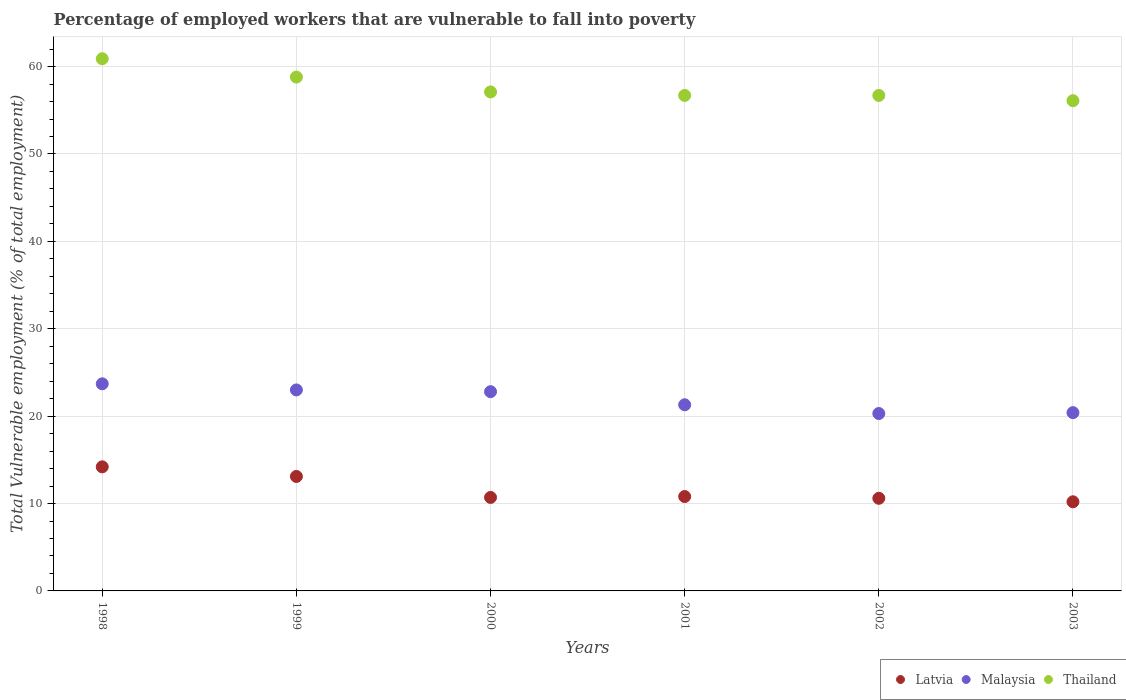How many different coloured dotlines are there?
Keep it short and to the point. 3. What is the percentage of employed workers who are vulnerable to fall into poverty in Malaysia in 2003?
Offer a terse response. 20.4. Across all years, what is the maximum percentage of employed workers who are vulnerable to fall into poverty in Malaysia?
Offer a very short reply. 23.7. Across all years, what is the minimum percentage of employed workers who are vulnerable to fall into poverty in Malaysia?
Give a very brief answer. 20.3. In which year was the percentage of employed workers who are vulnerable to fall into poverty in Malaysia minimum?
Offer a terse response. 2002. What is the total percentage of employed workers who are vulnerable to fall into poverty in Latvia in the graph?
Your answer should be compact. 69.6. What is the difference between the percentage of employed workers who are vulnerable to fall into poverty in Thailand in 2000 and that in 2002?
Your answer should be compact. 0.4. What is the difference between the percentage of employed workers who are vulnerable to fall into poverty in Malaysia in 2002 and the percentage of employed workers who are vulnerable to fall into poverty in Latvia in 2001?
Provide a succinct answer. 9.5. What is the average percentage of employed workers who are vulnerable to fall into poverty in Latvia per year?
Your answer should be compact. 11.6. In the year 1999, what is the difference between the percentage of employed workers who are vulnerable to fall into poverty in Thailand and percentage of employed workers who are vulnerable to fall into poverty in Latvia?
Your answer should be compact. 45.7. What is the ratio of the percentage of employed workers who are vulnerable to fall into poverty in Thailand in 2000 to that in 2002?
Your answer should be very brief. 1.01. What is the difference between the highest and the second highest percentage of employed workers who are vulnerable to fall into poverty in Malaysia?
Ensure brevity in your answer.  0.7. Is it the case that in every year, the sum of the percentage of employed workers who are vulnerable to fall into poverty in Latvia and percentage of employed workers who are vulnerable to fall into poverty in Malaysia  is greater than the percentage of employed workers who are vulnerable to fall into poverty in Thailand?
Provide a short and direct response. No. Does the percentage of employed workers who are vulnerable to fall into poverty in Latvia monotonically increase over the years?
Provide a short and direct response. No. Is the percentage of employed workers who are vulnerable to fall into poverty in Latvia strictly greater than the percentage of employed workers who are vulnerable to fall into poverty in Malaysia over the years?
Provide a short and direct response. No. How many dotlines are there?
Ensure brevity in your answer.  3. What is the difference between two consecutive major ticks on the Y-axis?
Provide a short and direct response. 10. Are the values on the major ticks of Y-axis written in scientific E-notation?
Your response must be concise. No. Does the graph contain any zero values?
Ensure brevity in your answer.  No. Does the graph contain grids?
Give a very brief answer. Yes. Where does the legend appear in the graph?
Provide a succinct answer. Bottom right. What is the title of the graph?
Keep it short and to the point. Percentage of employed workers that are vulnerable to fall into poverty. What is the label or title of the Y-axis?
Provide a short and direct response. Total Vulnerable employment (% of total employment). What is the Total Vulnerable employment (% of total employment) in Latvia in 1998?
Offer a terse response. 14.2. What is the Total Vulnerable employment (% of total employment) of Malaysia in 1998?
Your answer should be very brief. 23.7. What is the Total Vulnerable employment (% of total employment) of Thailand in 1998?
Offer a terse response. 60.9. What is the Total Vulnerable employment (% of total employment) in Latvia in 1999?
Provide a succinct answer. 13.1. What is the Total Vulnerable employment (% of total employment) in Malaysia in 1999?
Your response must be concise. 23. What is the Total Vulnerable employment (% of total employment) in Thailand in 1999?
Keep it short and to the point. 58.8. What is the Total Vulnerable employment (% of total employment) of Latvia in 2000?
Keep it short and to the point. 10.7. What is the Total Vulnerable employment (% of total employment) of Malaysia in 2000?
Your answer should be compact. 22.8. What is the Total Vulnerable employment (% of total employment) in Thailand in 2000?
Your response must be concise. 57.1. What is the Total Vulnerable employment (% of total employment) in Latvia in 2001?
Your response must be concise. 10.8. What is the Total Vulnerable employment (% of total employment) of Malaysia in 2001?
Provide a succinct answer. 21.3. What is the Total Vulnerable employment (% of total employment) of Thailand in 2001?
Offer a very short reply. 56.7. What is the Total Vulnerable employment (% of total employment) in Latvia in 2002?
Your answer should be very brief. 10.6. What is the Total Vulnerable employment (% of total employment) of Malaysia in 2002?
Your answer should be compact. 20.3. What is the Total Vulnerable employment (% of total employment) of Thailand in 2002?
Provide a short and direct response. 56.7. What is the Total Vulnerable employment (% of total employment) in Latvia in 2003?
Offer a terse response. 10.2. What is the Total Vulnerable employment (% of total employment) in Malaysia in 2003?
Keep it short and to the point. 20.4. What is the Total Vulnerable employment (% of total employment) of Thailand in 2003?
Make the answer very short. 56.1. Across all years, what is the maximum Total Vulnerable employment (% of total employment) of Latvia?
Give a very brief answer. 14.2. Across all years, what is the maximum Total Vulnerable employment (% of total employment) in Malaysia?
Give a very brief answer. 23.7. Across all years, what is the maximum Total Vulnerable employment (% of total employment) of Thailand?
Your answer should be very brief. 60.9. Across all years, what is the minimum Total Vulnerable employment (% of total employment) of Latvia?
Your response must be concise. 10.2. Across all years, what is the minimum Total Vulnerable employment (% of total employment) of Malaysia?
Your answer should be very brief. 20.3. Across all years, what is the minimum Total Vulnerable employment (% of total employment) of Thailand?
Ensure brevity in your answer.  56.1. What is the total Total Vulnerable employment (% of total employment) of Latvia in the graph?
Provide a succinct answer. 69.6. What is the total Total Vulnerable employment (% of total employment) in Malaysia in the graph?
Make the answer very short. 131.5. What is the total Total Vulnerable employment (% of total employment) in Thailand in the graph?
Your response must be concise. 346.3. What is the difference between the Total Vulnerable employment (% of total employment) in Latvia in 1998 and that in 1999?
Give a very brief answer. 1.1. What is the difference between the Total Vulnerable employment (% of total employment) of Malaysia in 1998 and that in 1999?
Provide a short and direct response. 0.7. What is the difference between the Total Vulnerable employment (% of total employment) of Thailand in 1998 and that in 1999?
Offer a very short reply. 2.1. What is the difference between the Total Vulnerable employment (% of total employment) of Latvia in 1998 and that in 2000?
Give a very brief answer. 3.5. What is the difference between the Total Vulnerable employment (% of total employment) in Thailand in 1998 and that in 2000?
Provide a short and direct response. 3.8. What is the difference between the Total Vulnerable employment (% of total employment) of Latvia in 1998 and that in 2001?
Your answer should be very brief. 3.4. What is the difference between the Total Vulnerable employment (% of total employment) of Malaysia in 1998 and that in 2001?
Your response must be concise. 2.4. What is the difference between the Total Vulnerable employment (% of total employment) in Latvia in 1998 and that in 2002?
Provide a succinct answer. 3.6. What is the difference between the Total Vulnerable employment (% of total employment) of Malaysia in 1998 and that in 2002?
Ensure brevity in your answer.  3.4. What is the difference between the Total Vulnerable employment (% of total employment) in Thailand in 1998 and that in 2002?
Offer a very short reply. 4.2. What is the difference between the Total Vulnerable employment (% of total employment) of Thailand in 1998 and that in 2003?
Give a very brief answer. 4.8. What is the difference between the Total Vulnerable employment (% of total employment) in Malaysia in 1999 and that in 2000?
Your answer should be compact. 0.2. What is the difference between the Total Vulnerable employment (% of total employment) in Thailand in 1999 and that in 2000?
Ensure brevity in your answer.  1.7. What is the difference between the Total Vulnerable employment (% of total employment) in Latvia in 1999 and that in 2001?
Offer a terse response. 2.3. What is the difference between the Total Vulnerable employment (% of total employment) of Thailand in 1999 and that in 2001?
Your response must be concise. 2.1. What is the difference between the Total Vulnerable employment (% of total employment) of Latvia in 1999 and that in 2002?
Give a very brief answer. 2.5. What is the difference between the Total Vulnerable employment (% of total employment) of Malaysia in 1999 and that in 2002?
Your answer should be compact. 2.7. What is the difference between the Total Vulnerable employment (% of total employment) of Thailand in 1999 and that in 2003?
Offer a very short reply. 2.7. What is the difference between the Total Vulnerable employment (% of total employment) in Latvia in 2000 and that in 2001?
Your response must be concise. -0.1. What is the difference between the Total Vulnerable employment (% of total employment) of Malaysia in 2000 and that in 2001?
Ensure brevity in your answer.  1.5. What is the difference between the Total Vulnerable employment (% of total employment) in Latvia in 2000 and that in 2002?
Ensure brevity in your answer.  0.1. What is the difference between the Total Vulnerable employment (% of total employment) in Malaysia in 2000 and that in 2002?
Your response must be concise. 2.5. What is the difference between the Total Vulnerable employment (% of total employment) of Latvia in 2000 and that in 2003?
Offer a very short reply. 0.5. What is the difference between the Total Vulnerable employment (% of total employment) of Latvia in 2001 and that in 2002?
Your answer should be very brief. 0.2. What is the difference between the Total Vulnerable employment (% of total employment) of Thailand in 2001 and that in 2002?
Offer a very short reply. 0. What is the difference between the Total Vulnerable employment (% of total employment) of Latvia in 2001 and that in 2003?
Your response must be concise. 0.6. What is the difference between the Total Vulnerable employment (% of total employment) in Malaysia in 2001 and that in 2003?
Make the answer very short. 0.9. What is the difference between the Total Vulnerable employment (% of total employment) in Thailand in 2001 and that in 2003?
Give a very brief answer. 0.6. What is the difference between the Total Vulnerable employment (% of total employment) in Latvia in 2002 and that in 2003?
Your answer should be very brief. 0.4. What is the difference between the Total Vulnerable employment (% of total employment) in Latvia in 1998 and the Total Vulnerable employment (% of total employment) in Malaysia in 1999?
Keep it short and to the point. -8.8. What is the difference between the Total Vulnerable employment (% of total employment) in Latvia in 1998 and the Total Vulnerable employment (% of total employment) in Thailand in 1999?
Your answer should be compact. -44.6. What is the difference between the Total Vulnerable employment (% of total employment) of Malaysia in 1998 and the Total Vulnerable employment (% of total employment) of Thailand in 1999?
Keep it short and to the point. -35.1. What is the difference between the Total Vulnerable employment (% of total employment) of Latvia in 1998 and the Total Vulnerable employment (% of total employment) of Thailand in 2000?
Provide a short and direct response. -42.9. What is the difference between the Total Vulnerable employment (% of total employment) of Malaysia in 1998 and the Total Vulnerable employment (% of total employment) of Thailand in 2000?
Ensure brevity in your answer.  -33.4. What is the difference between the Total Vulnerable employment (% of total employment) of Latvia in 1998 and the Total Vulnerable employment (% of total employment) of Malaysia in 2001?
Make the answer very short. -7.1. What is the difference between the Total Vulnerable employment (% of total employment) of Latvia in 1998 and the Total Vulnerable employment (% of total employment) of Thailand in 2001?
Your response must be concise. -42.5. What is the difference between the Total Vulnerable employment (% of total employment) of Malaysia in 1998 and the Total Vulnerable employment (% of total employment) of Thailand in 2001?
Your answer should be very brief. -33. What is the difference between the Total Vulnerable employment (% of total employment) of Latvia in 1998 and the Total Vulnerable employment (% of total employment) of Thailand in 2002?
Ensure brevity in your answer.  -42.5. What is the difference between the Total Vulnerable employment (% of total employment) of Malaysia in 1998 and the Total Vulnerable employment (% of total employment) of Thailand in 2002?
Your answer should be very brief. -33. What is the difference between the Total Vulnerable employment (% of total employment) of Latvia in 1998 and the Total Vulnerable employment (% of total employment) of Thailand in 2003?
Give a very brief answer. -41.9. What is the difference between the Total Vulnerable employment (% of total employment) in Malaysia in 1998 and the Total Vulnerable employment (% of total employment) in Thailand in 2003?
Ensure brevity in your answer.  -32.4. What is the difference between the Total Vulnerable employment (% of total employment) of Latvia in 1999 and the Total Vulnerable employment (% of total employment) of Malaysia in 2000?
Offer a terse response. -9.7. What is the difference between the Total Vulnerable employment (% of total employment) of Latvia in 1999 and the Total Vulnerable employment (% of total employment) of Thailand in 2000?
Your answer should be compact. -44. What is the difference between the Total Vulnerable employment (% of total employment) in Malaysia in 1999 and the Total Vulnerable employment (% of total employment) in Thailand in 2000?
Offer a terse response. -34.1. What is the difference between the Total Vulnerable employment (% of total employment) of Latvia in 1999 and the Total Vulnerable employment (% of total employment) of Malaysia in 2001?
Make the answer very short. -8.2. What is the difference between the Total Vulnerable employment (% of total employment) of Latvia in 1999 and the Total Vulnerable employment (% of total employment) of Thailand in 2001?
Provide a short and direct response. -43.6. What is the difference between the Total Vulnerable employment (% of total employment) of Malaysia in 1999 and the Total Vulnerable employment (% of total employment) of Thailand in 2001?
Ensure brevity in your answer.  -33.7. What is the difference between the Total Vulnerable employment (% of total employment) of Latvia in 1999 and the Total Vulnerable employment (% of total employment) of Thailand in 2002?
Give a very brief answer. -43.6. What is the difference between the Total Vulnerable employment (% of total employment) of Malaysia in 1999 and the Total Vulnerable employment (% of total employment) of Thailand in 2002?
Provide a short and direct response. -33.7. What is the difference between the Total Vulnerable employment (% of total employment) of Latvia in 1999 and the Total Vulnerable employment (% of total employment) of Thailand in 2003?
Your response must be concise. -43. What is the difference between the Total Vulnerable employment (% of total employment) in Malaysia in 1999 and the Total Vulnerable employment (% of total employment) in Thailand in 2003?
Provide a succinct answer. -33.1. What is the difference between the Total Vulnerable employment (% of total employment) in Latvia in 2000 and the Total Vulnerable employment (% of total employment) in Thailand in 2001?
Provide a short and direct response. -46. What is the difference between the Total Vulnerable employment (% of total employment) of Malaysia in 2000 and the Total Vulnerable employment (% of total employment) of Thailand in 2001?
Offer a terse response. -33.9. What is the difference between the Total Vulnerable employment (% of total employment) of Latvia in 2000 and the Total Vulnerable employment (% of total employment) of Malaysia in 2002?
Your answer should be compact. -9.6. What is the difference between the Total Vulnerable employment (% of total employment) in Latvia in 2000 and the Total Vulnerable employment (% of total employment) in Thailand in 2002?
Give a very brief answer. -46. What is the difference between the Total Vulnerable employment (% of total employment) in Malaysia in 2000 and the Total Vulnerable employment (% of total employment) in Thailand in 2002?
Your answer should be compact. -33.9. What is the difference between the Total Vulnerable employment (% of total employment) in Latvia in 2000 and the Total Vulnerable employment (% of total employment) in Malaysia in 2003?
Ensure brevity in your answer.  -9.7. What is the difference between the Total Vulnerable employment (% of total employment) in Latvia in 2000 and the Total Vulnerable employment (% of total employment) in Thailand in 2003?
Provide a succinct answer. -45.4. What is the difference between the Total Vulnerable employment (% of total employment) of Malaysia in 2000 and the Total Vulnerable employment (% of total employment) of Thailand in 2003?
Provide a succinct answer. -33.3. What is the difference between the Total Vulnerable employment (% of total employment) of Latvia in 2001 and the Total Vulnerable employment (% of total employment) of Malaysia in 2002?
Provide a short and direct response. -9.5. What is the difference between the Total Vulnerable employment (% of total employment) of Latvia in 2001 and the Total Vulnerable employment (% of total employment) of Thailand in 2002?
Ensure brevity in your answer.  -45.9. What is the difference between the Total Vulnerable employment (% of total employment) of Malaysia in 2001 and the Total Vulnerable employment (% of total employment) of Thailand in 2002?
Keep it short and to the point. -35.4. What is the difference between the Total Vulnerable employment (% of total employment) of Latvia in 2001 and the Total Vulnerable employment (% of total employment) of Malaysia in 2003?
Ensure brevity in your answer.  -9.6. What is the difference between the Total Vulnerable employment (% of total employment) in Latvia in 2001 and the Total Vulnerable employment (% of total employment) in Thailand in 2003?
Provide a succinct answer. -45.3. What is the difference between the Total Vulnerable employment (% of total employment) of Malaysia in 2001 and the Total Vulnerable employment (% of total employment) of Thailand in 2003?
Keep it short and to the point. -34.8. What is the difference between the Total Vulnerable employment (% of total employment) in Latvia in 2002 and the Total Vulnerable employment (% of total employment) in Thailand in 2003?
Give a very brief answer. -45.5. What is the difference between the Total Vulnerable employment (% of total employment) of Malaysia in 2002 and the Total Vulnerable employment (% of total employment) of Thailand in 2003?
Ensure brevity in your answer.  -35.8. What is the average Total Vulnerable employment (% of total employment) in Malaysia per year?
Your answer should be compact. 21.92. What is the average Total Vulnerable employment (% of total employment) in Thailand per year?
Offer a very short reply. 57.72. In the year 1998, what is the difference between the Total Vulnerable employment (% of total employment) of Latvia and Total Vulnerable employment (% of total employment) of Malaysia?
Your response must be concise. -9.5. In the year 1998, what is the difference between the Total Vulnerable employment (% of total employment) in Latvia and Total Vulnerable employment (% of total employment) in Thailand?
Ensure brevity in your answer.  -46.7. In the year 1998, what is the difference between the Total Vulnerable employment (% of total employment) of Malaysia and Total Vulnerable employment (% of total employment) of Thailand?
Provide a succinct answer. -37.2. In the year 1999, what is the difference between the Total Vulnerable employment (% of total employment) of Latvia and Total Vulnerable employment (% of total employment) of Malaysia?
Provide a succinct answer. -9.9. In the year 1999, what is the difference between the Total Vulnerable employment (% of total employment) in Latvia and Total Vulnerable employment (% of total employment) in Thailand?
Your response must be concise. -45.7. In the year 1999, what is the difference between the Total Vulnerable employment (% of total employment) in Malaysia and Total Vulnerable employment (% of total employment) in Thailand?
Your answer should be very brief. -35.8. In the year 2000, what is the difference between the Total Vulnerable employment (% of total employment) of Latvia and Total Vulnerable employment (% of total employment) of Malaysia?
Your answer should be very brief. -12.1. In the year 2000, what is the difference between the Total Vulnerable employment (% of total employment) in Latvia and Total Vulnerable employment (% of total employment) in Thailand?
Your answer should be compact. -46.4. In the year 2000, what is the difference between the Total Vulnerable employment (% of total employment) in Malaysia and Total Vulnerable employment (% of total employment) in Thailand?
Give a very brief answer. -34.3. In the year 2001, what is the difference between the Total Vulnerable employment (% of total employment) of Latvia and Total Vulnerable employment (% of total employment) of Malaysia?
Keep it short and to the point. -10.5. In the year 2001, what is the difference between the Total Vulnerable employment (% of total employment) in Latvia and Total Vulnerable employment (% of total employment) in Thailand?
Your answer should be very brief. -45.9. In the year 2001, what is the difference between the Total Vulnerable employment (% of total employment) of Malaysia and Total Vulnerable employment (% of total employment) of Thailand?
Your answer should be very brief. -35.4. In the year 2002, what is the difference between the Total Vulnerable employment (% of total employment) in Latvia and Total Vulnerable employment (% of total employment) in Malaysia?
Provide a short and direct response. -9.7. In the year 2002, what is the difference between the Total Vulnerable employment (% of total employment) of Latvia and Total Vulnerable employment (% of total employment) of Thailand?
Give a very brief answer. -46.1. In the year 2002, what is the difference between the Total Vulnerable employment (% of total employment) in Malaysia and Total Vulnerable employment (% of total employment) in Thailand?
Offer a very short reply. -36.4. In the year 2003, what is the difference between the Total Vulnerable employment (% of total employment) of Latvia and Total Vulnerable employment (% of total employment) of Malaysia?
Ensure brevity in your answer.  -10.2. In the year 2003, what is the difference between the Total Vulnerable employment (% of total employment) of Latvia and Total Vulnerable employment (% of total employment) of Thailand?
Provide a short and direct response. -45.9. In the year 2003, what is the difference between the Total Vulnerable employment (% of total employment) of Malaysia and Total Vulnerable employment (% of total employment) of Thailand?
Ensure brevity in your answer.  -35.7. What is the ratio of the Total Vulnerable employment (% of total employment) in Latvia in 1998 to that in 1999?
Your response must be concise. 1.08. What is the ratio of the Total Vulnerable employment (% of total employment) in Malaysia in 1998 to that in 1999?
Your answer should be very brief. 1.03. What is the ratio of the Total Vulnerable employment (% of total employment) in Thailand in 1998 to that in 1999?
Ensure brevity in your answer.  1.04. What is the ratio of the Total Vulnerable employment (% of total employment) of Latvia in 1998 to that in 2000?
Give a very brief answer. 1.33. What is the ratio of the Total Vulnerable employment (% of total employment) of Malaysia in 1998 to that in 2000?
Keep it short and to the point. 1.04. What is the ratio of the Total Vulnerable employment (% of total employment) of Thailand in 1998 to that in 2000?
Ensure brevity in your answer.  1.07. What is the ratio of the Total Vulnerable employment (% of total employment) in Latvia in 1998 to that in 2001?
Offer a terse response. 1.31. What is the ratio of the Total Vulnerable employment (% of total employment) in Malaysia in 1998 to that in 2001?
Offer a very short reply. 1.11. What is the ratio of the Total Vulnerable employment (% of total employment) in Thailand in 1998 to that in 2001?
Your answer should be very brief. 1.07. What is the ratio of the Total Vulnerable employment (% of total employment) in Latvia in 1998 to that in 2002?
Offer a terse response. 1.34. What is the ratio of the Total Vulnerable employment (% of total employment) in Malaysia in 1998 to that in 2002?
Ensure brevity in your answer.  1.17. What is the ratio of the Total Vulnerable employment (% of total employment) in Thailand in 1998 to that in 2002?
Provide a short and direct response. 1.07. What is the ratio of the Total Vulnerable employment (% of total employment) in Latvia in 1998 to that in 2003?
Your response must be concise. 1.39. What is the ratio of the Total Vulnerable employment (% of total employment) in Malaysia in 1998 to that in 2003?
Give a very brief answer. 1.16. What is the ratio of the Total Vulnerable employment (% of total employment) in Thailand in 1998 to that in 2003?
Provide a succinct answer. 1.09. What is the ratio of the Total Vulnerable employment (% of total employment) in Latvia in 1999 to that in 2000?
Your response must be concise. 1.22. What is the ratio of the Total Vulnerable employment (% of total employment) of Malaysia in 1999 to that in 2000?
Make the answer very short. 1.01. What is the ratio of the Total Vulnerable employment (% of total employment) in Thailand in 1999 to that in 2000?
Ensure brevity in your answer.  1.03. What is the ratio of the Total Vulnerable employment (% of total employment) in Latvia in 1999 to that in 2001?
Keep it short and to the point. 1.21. What is the ratio of the Total Vulnerable employment (% of total employment) of Malaysia in 1999 to that in 2001?
Ensure brevity in your answer.  1.08. What is the ratio of the Total Vulnerable employment (% of total employment) in Latvia in 1999 to that in 2002?
Your answer should be compact. 1.24. What is the ratio of the Total Vulnerable employment (% of total employment) of Malaysia in 1999 to that in 2002?
Your response must be concise. 1.13. What is the ratio of the Total Vulnerable employment (% of total employment) of Thailand in 1999 to that in 2002?
Offer a terse response. 1.04. What is the ratio of the Total Vulnerable employment (% of total employment) of Latvia in 1999 to that in 2003?
Offer a very short reply. 1.28. What is the ratio of the Total Vulnerable employment (% of total employment) in Malaysia in 1999 to that in 2003?
Provide a succinct answer. 1.13. What is the ratio of the Total Vulnerable employment (% of total employment) in Thailand in 1999 to that in 2003?
Offer a terse response. 1.05. What is the ratio of the Total Vulnerable employment (% of total employment) of Malaysia in 2000 to that in 2001?
Provide a short and direct response. 1.07. What is the ratio of the Total Vulnerable employment (% of total employment) in Thailand in 2000 to that in 2001?
Offer a terse response. 1.01. What is the ratio of the Total Vulnerable employment (% of total employment) in Latvia in 2000 to that in 2002?
Keep it short and to the point. 1.01. What is the ratio of the Total Vulnerable employment (% of total employment) of Malaysia in 2000 to that in 2002?
Give a very brief answer. 1.12. What is the ratio of the Total Vulnerable employment (% of total employment) in Thailand in 2000 to that in 2002?
Provide a succinct answer. 1.01. What is the ratio of the Total Vulnerable employment (% of total employment) in Latvia in 2000 to that in 2003?
Offer a terse response. 1.05. What is the ratio of the Total Vulnerable employment (% of total employment) in Malaysia in 2000 to that in 2003?
Make the answer very short. 1.12. What is the ratio of the Total Vulnerable employment (% of total employment) in Thailand in 2000 to that in 2003?
Your answer should be very brief. 1.02. What is the ratio of the Total Vulnerable employment (% of total employment) in Latvia in 2001 to that in 2002?
Your answer should be compact. 1.02. What is the ratio of the Total Vulnerable employment (% of total employment) of Malaysia in 2001 to that in 2002?
Give a very brief answer. 1.05. What is the ratio of the Total Vulnerable employment (% of total employment) in Thailand in 2001 to that in 2002?
Ensure brevity in your answer.  1. What is the ratio of the Total Vulnerable employment (% of total employment) of Latvia in 2001 to that in 2003?
Make the answer very short. 1.06. What is the ratio of the Total Vulnerable employment (% of total employment) in Malaysia in 2001 to that in 2003?
Offer a very short reply. 1.04. What is the ratio of the Total Vulnerable employment (% of total employment) in Thailand in 2001 to that in 2003?
Offer a terse response. 1.01. What is the ratio of the Total Vulnerable employment (% of total employment) in Latvia in 2002 to that in 2003?
Offer a very short reply. 1.04. What is the ratio of the Total Vulnerable employment (% of total employment) in Malaysia in 2002 to that in 2003?
Keep it short and to the point. 1. What is the ratio of the Total Vulnerable employment (% of total employment) of Thailand in 2002 to that in 2003?
Your response must be concise. 1.01. What is the difference between the highest and the second highest Total Vulnerable employment (% of total employment) of Latvia?
Your answer should be very brief. 1.1. What is the difference between the highest and the second highest Total Vulnerable employment (% of total employment) in Thailand?
Make the answer very short. 2.1. What is the difference between the highest and the lowest Total Vulnerable employment (% of total employment) of Latvia?
Your response must be concise. 4. What is the difference between the highest and the lowest Total Vulnerable employment (% of total employment) of Malaysia?
Provide a succinct answer. 3.4. What is the difference between the highest and the lowest Total Vulnerable employment (% of total employment) in Thailand?
Provide a short and direct response. 4.8. 